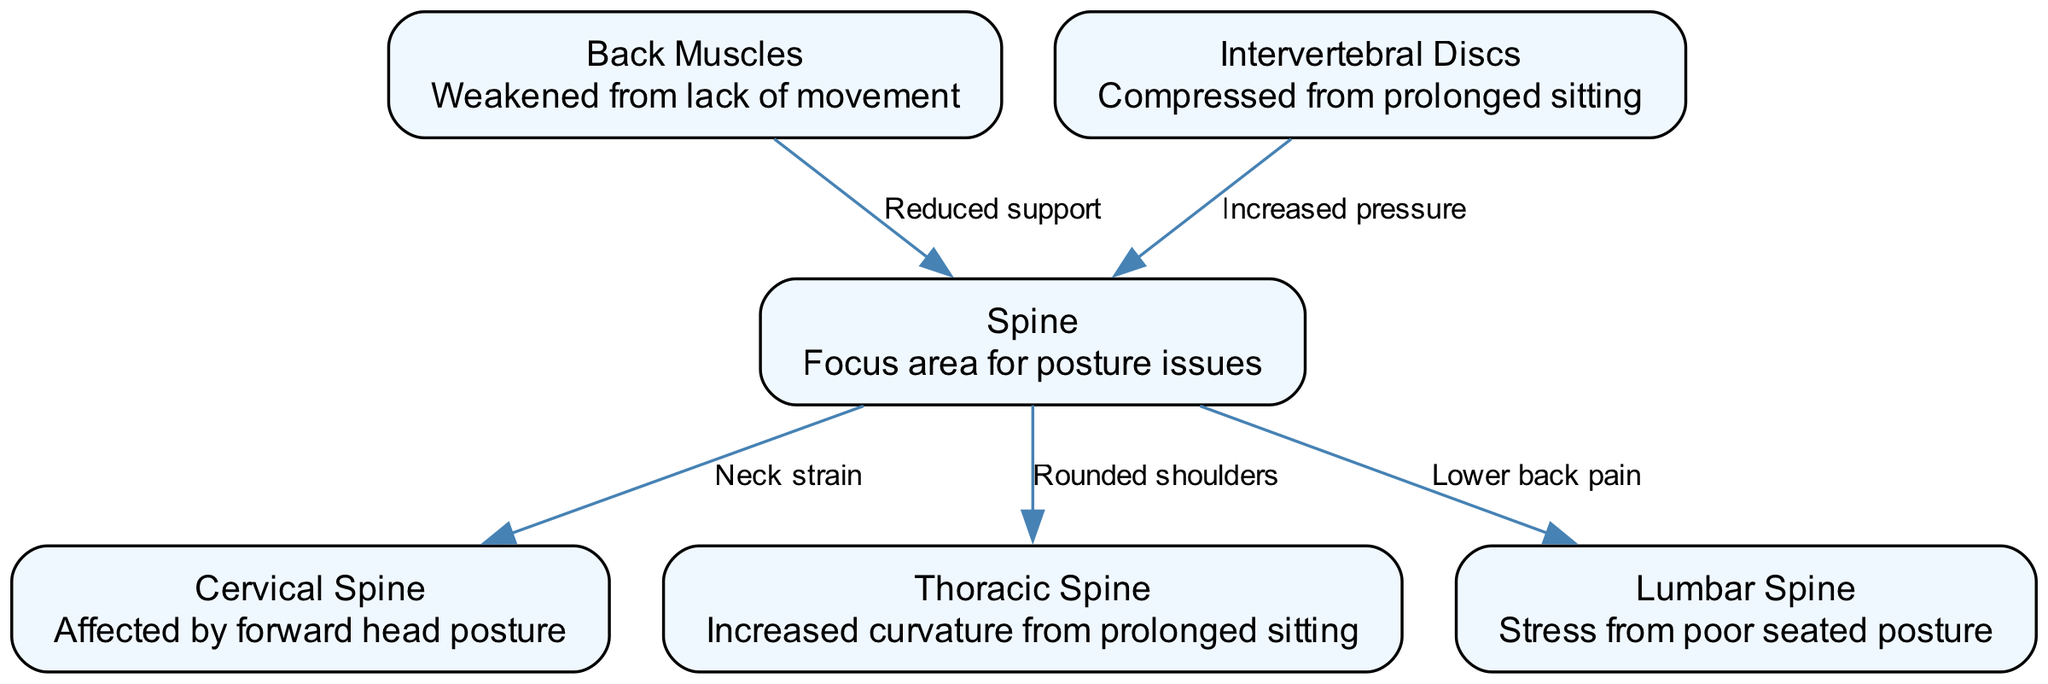What is the total number of nodes in the diagram? The diagram contains six nodes related to spinal health and posture issues: Spine, Cervical Spine, Thoracic Spine, Lumbar Spine, Back Muscles, and Intervertebral Discs. Counting these gives us a total of six nodes.
Answer: 6 Which node is responsible for lower back pain? The diagram indicates that the Lumbar Spine is associated with lower back pain, as shown by the edge connecting Spine to Lumbar Spine labeled "Lower back pain."
Answer: Lumbar Spine How many edges are present in the diagram? There are five edges connecting different nodes in the diagram, representing various relationships and effects among the components related to spinal health. Counting these gives us a total of five edges.
Answer: 5 What condition is indicated by the edge between the Spine and the Thoracic Spine? The edge labeled "Rounded shoulders" connects the Spine to the Thoracic Spine, indicating that this condition arises from the alignment issues related to prolonged sitting.
Answer: Rounded shoulders Which spine section is affected by forward head posture? The Cervical Spine is highlighted as being affected by forward head posture, demonstrated by the edge pointing from Spine to Cervical Spine marked "Neck strain."
Answer: Cervical Spine Explain the relationship between Back Muscles and Spine. The Back Muscles node points to the Spine with an edge labeled "Reduced support," indicating that weakened muscles due to lack of movement contribute to poor spinal support, which can lead to posture problems.
Answer: Reduced support What impact does prolonged sitting have on Intervertebral Discs? The diagram shows that the Intervertebral Discs experience "Increased pressure" from prolonged sitting, indicating a negative impact on their health due to improper seating posture.
Answer: Increased pressure How does poor seated posture affect the Lumbar Spine? Poor seated posture increases stress on the Lumbar Spine, as indicated by the edge from Spine to Lumbar labeled "Lower back pain," demonstrating the resulting discomfort from such postures.
Answer: Stress What can be inferred about the relationship between spinal health and office workers? The diagram implies that prolonged sitting leads to various spinal health issues such as neck strain, rounded shoulders, lower back pain, and increased pressure on intervertebral discs, highlighting the risks associated with office work.
Answer: Various spinal health issues 